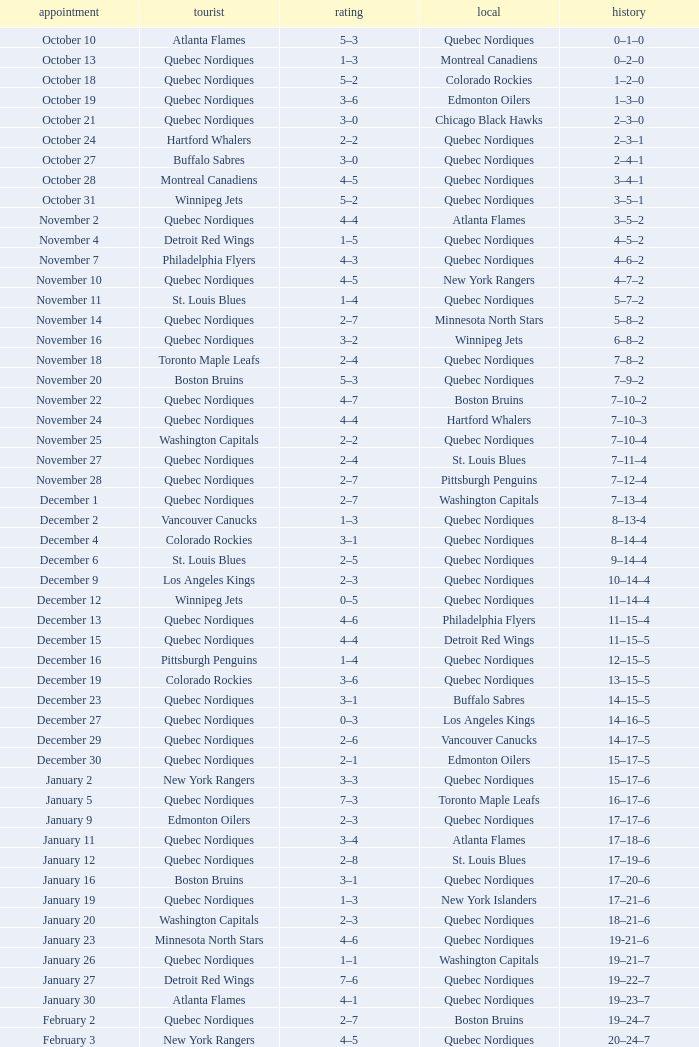Write the full table. {'header': ['appointment', 'tourist', 'rating', 'local', 'history'], 'rows': [['October 10', 'Atlanta Flames', '5–3', 'Quebec Nordiques', '0–1–0'], ['October 13', 'Quebec Nordiques', '1–3', 'Montreal Canadiens', '0–2–0'], ['October 18', 'Quebec Nordiques', '5–2', 'Colorado Rockies', '1–2–0'], ['October 19', 'Quebec Nordiques', '3–6', 'Edmonton Oilers', '1–3–0'], ['October 21', 'Quebec Nordiques', '3–0', 'Chicago Black Hawks', '2–3–0'], ['October 24', 'Hartford Whalers', '2–2', 'Quebec Nordiques', '2–3–1'], ['October 27', 'Buffalo Sabres', '3–0', 'Quebec Nordiques', '2–4–1'], ['October 28', 'Montreal Canadiens', '4–5', 'Quebec Nordiques', '3–4–1'], ['October 31', 'Winnipeg Jets', '5–2', 'Quebec Nordiques', '3–5–1'], ['November 2', 'Quebec Nordiques', '4–4', 'Atlanta Flames', '3–5–2'], ['November 4', 'Detroit Red Wings', '1–5', 'Quebec Nordiques', '4–5–2'], ['November 7', 'Philadelphia Flyers', '4–3', 'Quebec Nordiques', '4–6–2'], ['November 10', 'Quebec Nordiques', '4–5', 'New York Rangers', '4–7–2'], ['November 11', 'St. Louis Blues', '1–4', 'Quebec Nordiques', '5–7–2'], ['November 14', 'Quebec Nordiques', '2–7', 'Minnesota North Stars', '5–8–2'], ['November 16', 'Quebec Nordiques', '3–2', 'Winnipeg Jets', '6–8–2'], ['November 18', 'Toronto Maple Leafs', '2–4', 'Quebec Nordiques', '7–8–2'], ['November 20', 'Boston Bruins', '5–3', 'Quebec Nordiques', '7–9–2'], ['November 22', 'Quebec Nordiques', '4–7', 'Boston Bruins', '7–10–2'], ['November 24', 'Quebec Nordiques', '4–4', 'Hartford Whalers', '7–10–3'], ['November 25', 'Washington Capitals', '2–2', 'Quebec Nordiques', '7–10–4'], ['November 27', 'Quebec Nordiques', '2–4', 'St. Louis Blues', '7–11–4'], ['November 28', 'Quebec Nordiques', '2–7', 'Pittsburgh Penguins', '7–12–4'], ['December 1', 'Quebec Nordiques', '2–7', 'Washington Capitals', '7–13–4'], ['December 2', 'Vancouver Canucks', '1–3', 'Quebec Nordiques', '8–13-4'], ['December 4', 'Colorado Rockies', '3–1', 'Quebec Nordiques', '8–14–4'], ['December 6', 'St. Louis Blues', '2–5', 'Quebec Nordiques', '9–14–4'], ['December 9', 'Los Angeles Kings', '2–3', 'Quebec Nordiques', '10–14–4'], ['December 12', 'Winnipeg Jets', '0–5', 'Quebec Nordiques', '11–14–4'], ['December 13', 'Quebec Nordiques', '4–6', 'Philadelphia Flyers', '11–15–4'], ['December 15', 'Quebec Nordiques', '4–4', 'Detroit Red Wings', '11–15–5'], ['December 16', 'Pittsburgh Penguins', '1–4', 'Quebec Nordiques', '12–15–5'], ['December 19', 'Colorado Rockies', '3–6', 'Quebec Nordiques', '13–15–5'], ['December 23', 'Quebec Nordiques', '3–1', 'Buffalo Sabres', '14–15–5'], ['December 27', 'Quebec Nordiques', '0–3', 'Los Angeles Kings', '14–16–5'], ['December 29', 'Quebec Nordiques', '2–6', 'Vancouver Canucks', '14–17–5'], ['December 30', 'Quebec Nordiques', '2–1', 'Edmonton Oilers', '15–17–5'], ['January 2', 'New York Rangers', '3–3', 'Quebec Nordiques', '15–17–6'], ['January 5', 'Quebec Nordiques', '7–3', 'Toronto Maple Leafs', '16–17–6'], ['January 9', 'Edmonton Oilers', '2–3', 'Quebec Nordiques', '17–17–6'], ['January 11', 'Quebec Nordiques', '3–4', 'Atlanta Flames', '17–18–6'], ['January 12', 'Quebec Nordiques', '2–8', 'St. Louis Blues', '17–19–6'], ['January 16', 'Boston Bruins', '3–1', 'Quebec Nordiques', '17–20–6'], ['January 19', 'Quebec Nordiques', '1–3', 'New York Islanders', '17–21–6'], ['January 20', 'Washington Capitals', '2–3', 'Quebec Nordiques', '18–21–6'], ['January 23', 'Minnesota North Stars', '4–6', 'Quebec Nordiques', '19-21–6'], ['January 26', 'Quebec Nordiques', '1–1', 'Washington Capitals', '19–21–7'], ['January 27', 'Detroit Red Wings', '7–6', 'Quebec Nordiques', '19–22–7'], ['January 30', 'Atlanta Flames', '4–1', 'Quebec Nordiques', '19–23–7'], ['February 2', 'Quebec Nordiques', '2–7', 'Boston Bruins', '19–24–7'], ['February 3', 'New York Rangers', '4–5', 'Quebec Nordiques', '20–24–7'], ['February 6', 'Chicago Black Hawks', '3–3', 'Quebec Nordiques', '20–24–8'], ['February 9', 'Quebec Nordiques', '0–5', 'New York Islanders', '20–25–8'], ['February 10', 'Quebec Nordiques', '1–3', 'New York Rangers', '20–26–8'], ['February 14', 'Quebec Nordiques', '1–5', 'Montreal Canadiens', '20–27–8'], ['February 17', 'Quebec Nordiques', '5–6', 'Winnipeg Jets', '20–28–8'], ['February 18', 'Quebec Nordiques', '2–6', 'Minnesota North Stars', '20–29–8'], ['February 19', 'Buffalo Sabres', '3–1', 'Quebec Nordiques', '20–30–8'], ['February 23', 'Quebec Nordiques', '1–2', 'Pittsburgh Penguins', '20–31–8'], ['February 24', 'Pittsburgh Penguins', '0–2', 'Quebec Nordiques', '21–31–8'], ['February 26', 'Hartford Whalers', '5–9', 'Quebec Nordiques', '22–31–8'], ['February 27', 'New York Islanders', '5–3', 'Quebec Nordiques', '22–32–8'], ['March 2', 'Los Angeles Kings', '4–3', 'Quebec Nordiques', '22–33–8'], ['March 5', 'Minnesota North Stars', '3-3', 'Quebec Nordiques', '22–33–9'], ['March 8', 'Quebec Nordiques', '2–3', 'Toronto Maple Leafs', '22–34–9'], ['March 9', 'Toronto Maple Leafs', '4–5', 'Quebec Nordiques', '23–34-9'], ['March 12', 'Edmonton Oilers', '6–3', 'Quebec Nordiques', '23–35–9'], ['March 16', 'Vancouver Canucks', '3–2', 'Quebec Nordiques', '23–36–9'], ['March 19', 'Quebec Nordiques', '2–5', 'Chicago Black Hawks', '23–37–9'], ['March 20', 'Quebec Nordiques', '6–2', 'Colorado Rockies', '24–37–9'], ['March 22', 'Quebec Nordiques', '1-4', 'Los Angeles Kings', '24–38-9'], ['March 23', 'Quebec Nordiques', '6–2', 'Vancouver Canucks', '25–38–9'], ['March 26', 'Chicago Black Hawks', '7–2', 'Quebec Nordiques', '25–39–9'], ['March 27', 'Quebec Nordiques', '2–5', 'Philadelphia Flyers', '25–40–9'], ['March 29', 'Quebec Nordiques', '7–9', 'Detroit Red Wings', '25–41–9'], ['March 30', 'New York Islanders', '9–6', 'Quebec Nordiques', '25–42–9'], ['April 1', 'Philadelphia Flyers', '3–3', 'Quebec Nordiques', '25–42–10'], ['April 3', 'Quebec Nordiques', '3–8', 'Buffalo Sabres', '25–43–10'], ['April 4', 'Quebec Nordiques', '2–9', 'Hartford Whalers', '25–44–10'], ['April 6', 'Montreal Canadiens', '4–4', 'Quebec Nordiques', '25–44–11']]} Which Home has a Record of 16–17–6? Toronto Maple Leafs. 